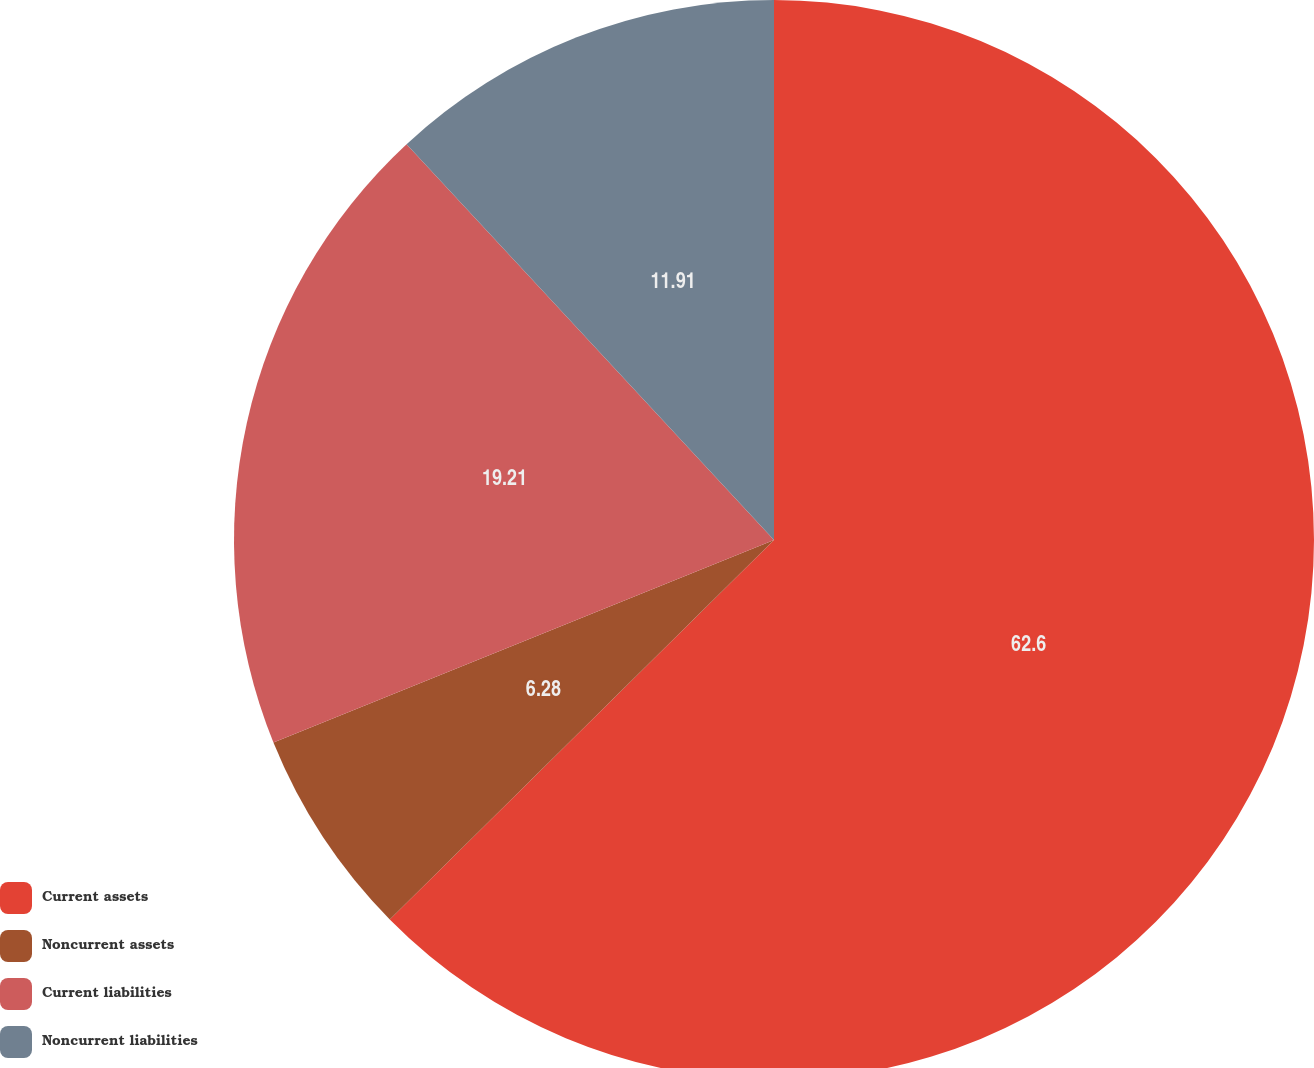<chart> <loc_0><loc_0><loc_500><loc_500><pie_chart><fcel>Current assets<fcel>Noncurrent assets<fcel>Current liabilities<fcel>Noncurrent liabilities<nl><fcel>62.6%<fcel>6.28%<fcel>19.21%<fcel>11.91%<nl></chart> 